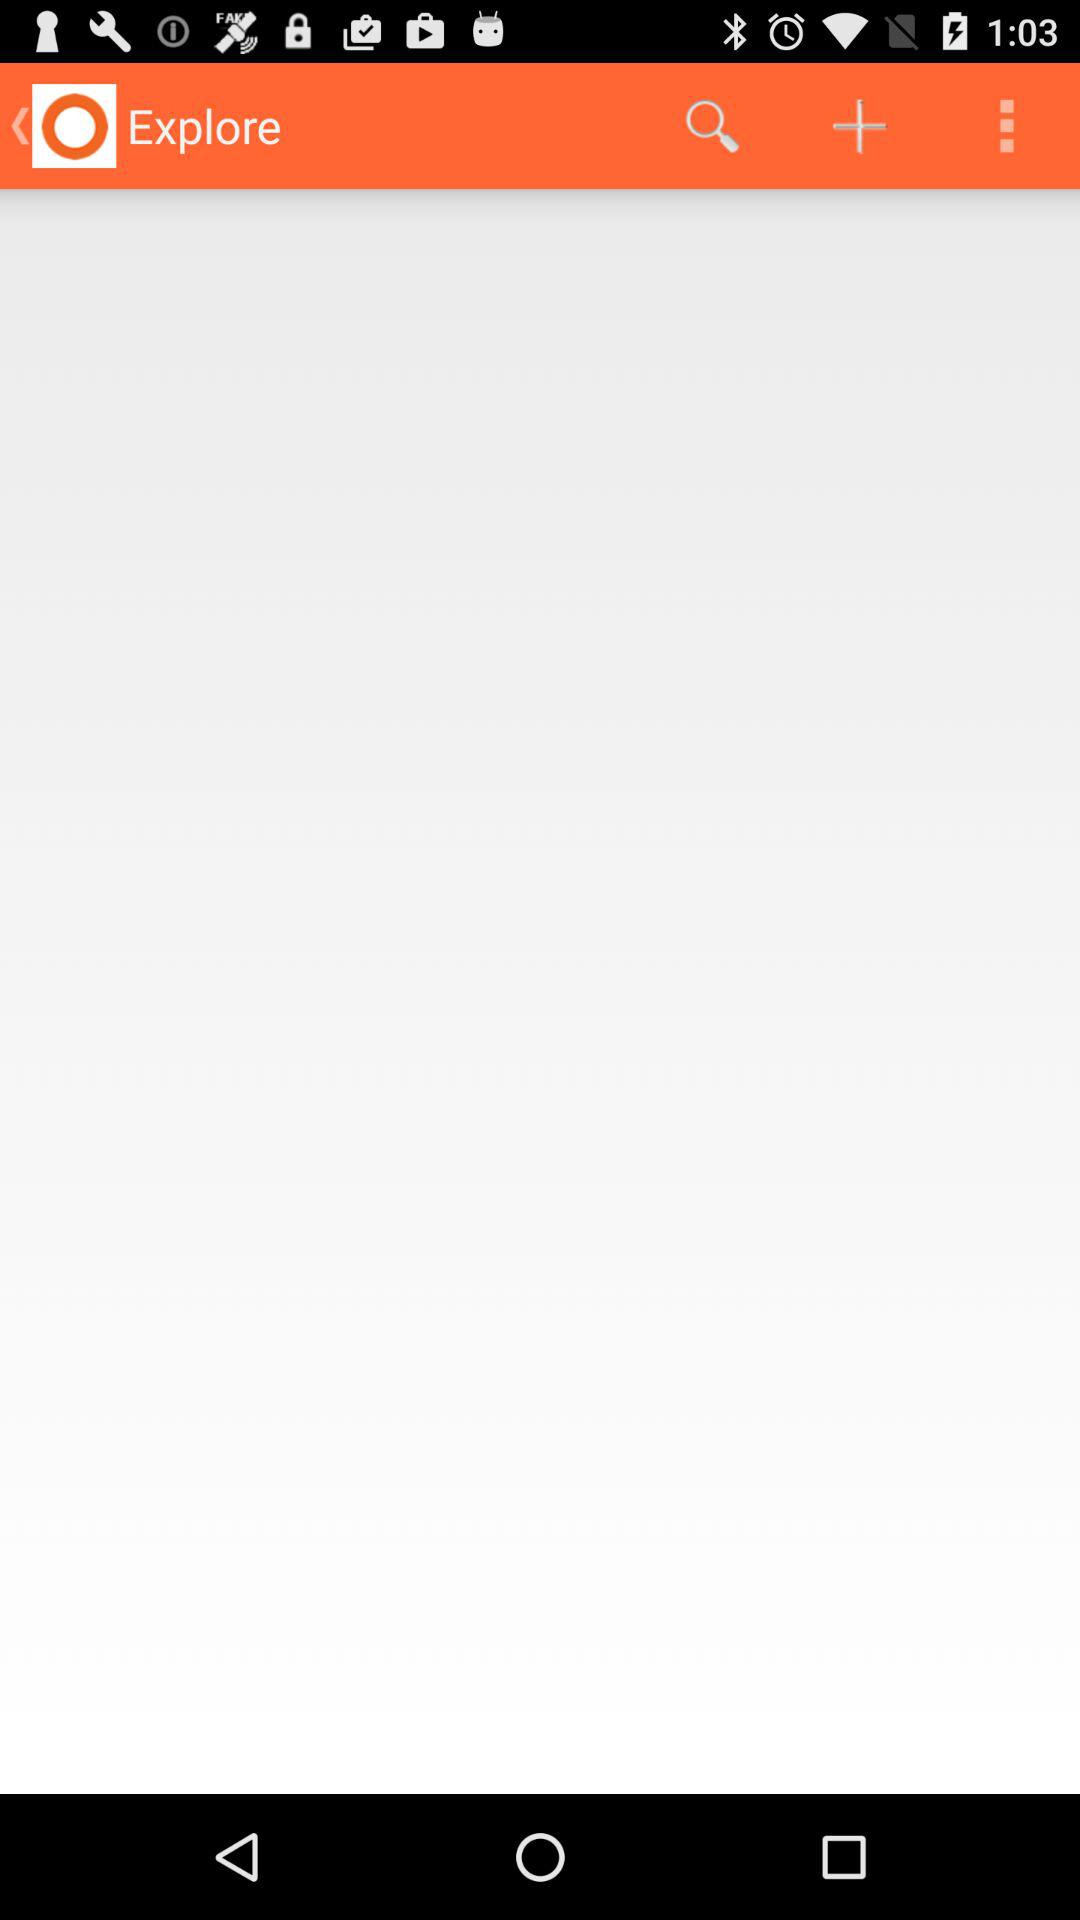How many more dots are there than arrows?
Answer the question using a single word or phrase. 2 